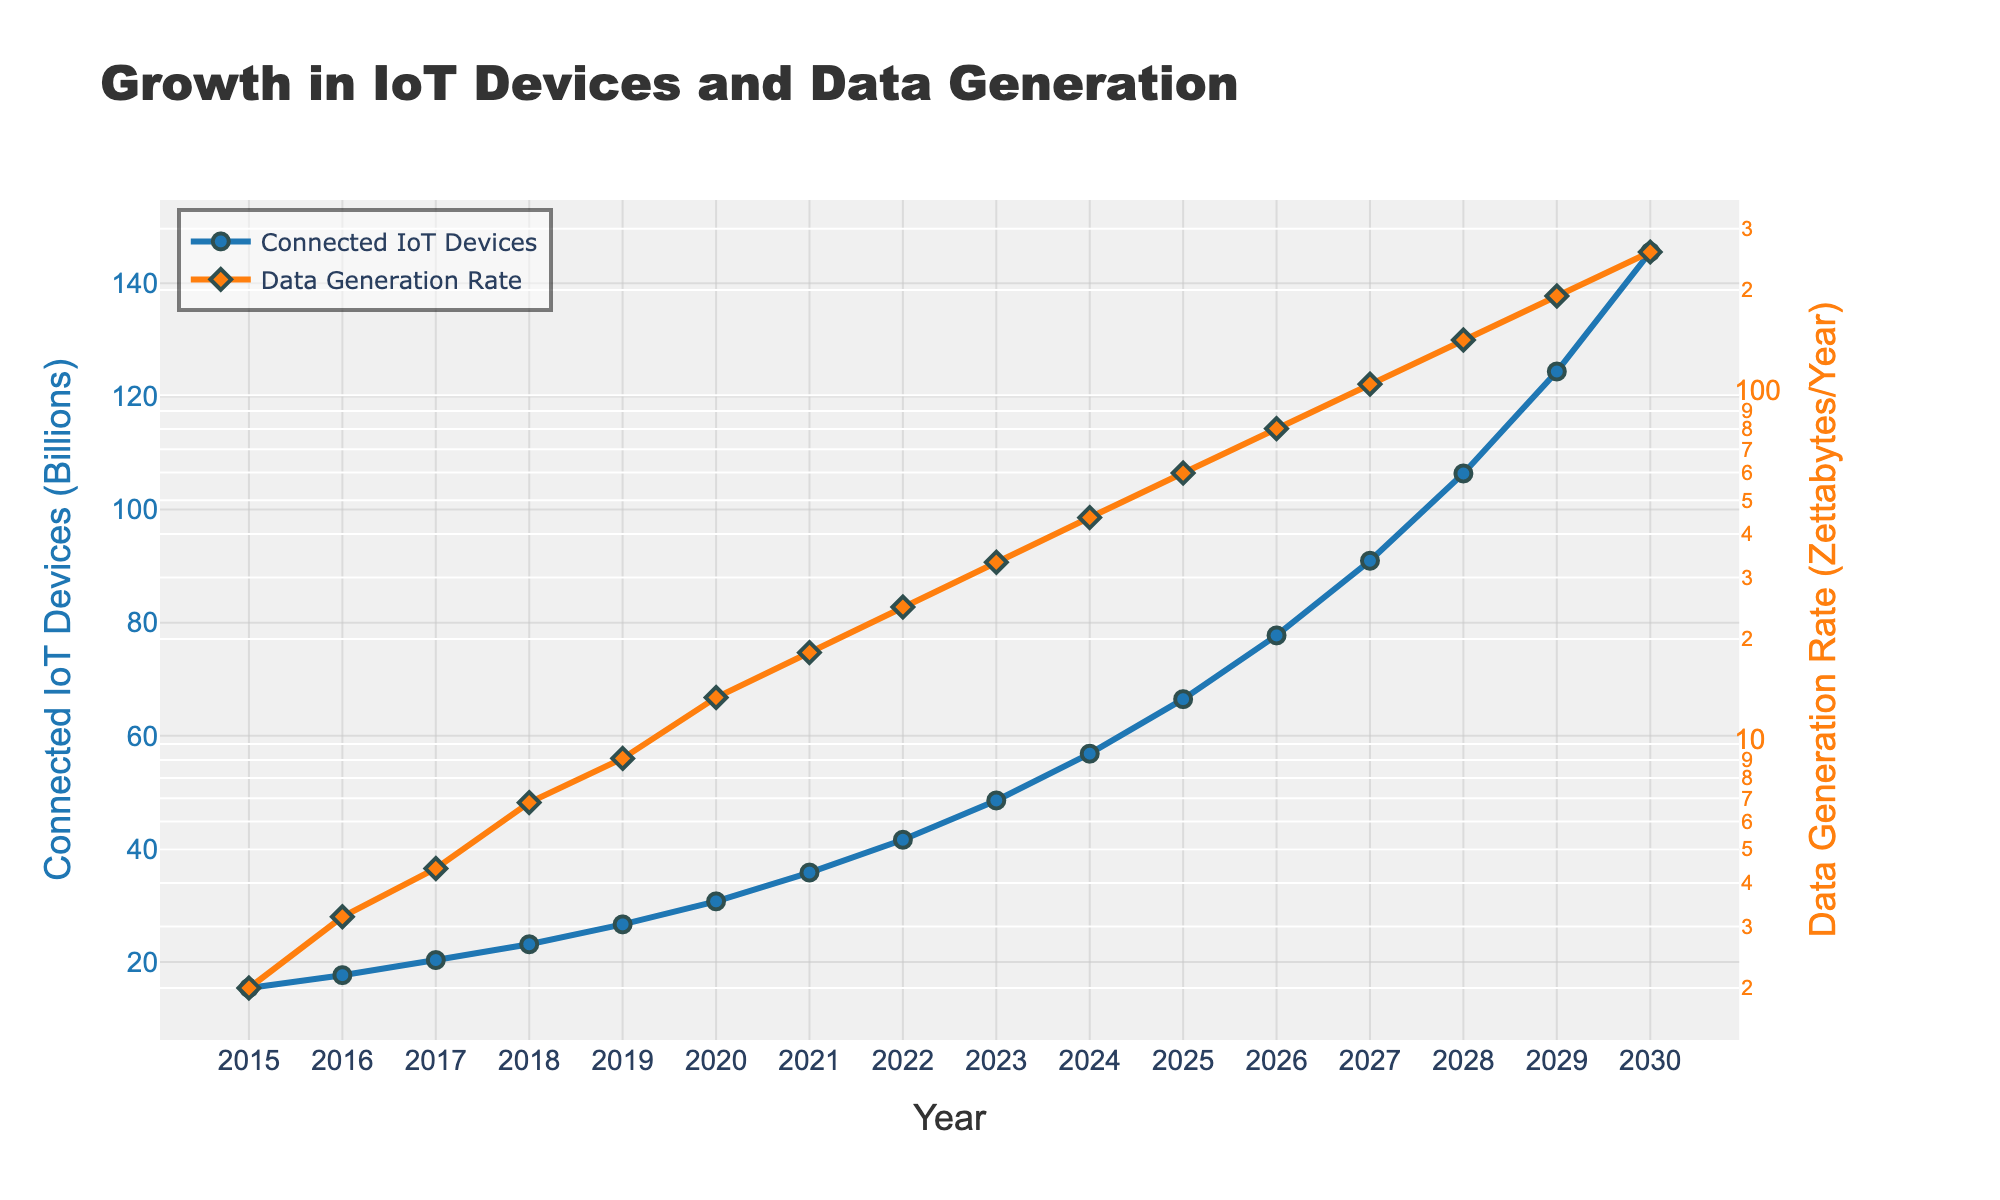What is the data generation rate in 2023? In 2023, the line with the diamond markers for the data generation rate indicates 33.2 Zettabytes/Year.
Answer: 33.2 Zettabytes/Year Which year saw the number of connected IoT devices first exceed 50 billion? The graph shows that in 2024, the amount of connected IoT devices reaches 56.84 billion, marking the first year above 50 billion.
Answer: 2024 What is the rate of increase in connected IoT devices between 2017 and 2020? Subtract the 2017 value from the 2020 value: 30.73 billion (2020) - 20.35 billion (2017) = 10.38 billion.
Answer: 10.38 billion By how much did the data generation rate increase from 2015 to 2030? Subtract the data generation rate in 2015 from the rate in 2030: 257.2 Zettabytes/Year (2030) - 2 Zettabytes/Year (2015) = 255.2 Zettabytes/Year.
Answer: 255.2 Zettabytes/Year Which increased more between 2019 and 2026, the number of connected IoT devices or the data generation rate? Connected IoT devices increased from 26.66 billion (2019) to 77.75 billion (2026), a rise of 51.09 billion. Data generation rate increased from 9.1 Zettabytes/Year (2019) to 80.2 Zettabytes/Year (2026), a rise of 71.1 Zettabytes/Year.
Answer: Data generation rate What is the average number of connected IoT devices from 2015 to 2020? Sum the values from 2015 to 2020, then divide by the number of years: (15.41 + 17.68 + 20.35 + 23.14 + 26.66 + 30.73) / 6 = 22.66 billion (approx).
Answer: 22.66 billion In which year did the data generation rate experience the largest single-year growth, and what was the amount? The largest growth occurs between 2022 and 2023, increasing from 24.7 to 33.2 zettabytes/year, a difference of 8.5 zettabytes/year.
Answer: 2023, 8.5 zettabytes/year How does the trend in the number of connected IoT devices compare to the trend in the data generation rate over the years? Both trends show a consistent increase over the years, but the data generation rate follows a steeper upward trend when viewed on a logarithmic scale, indicating an exponential growth compared to a more linear growth in IoT devices.
Answer: Exponential What's the approximate ratio of data generation rate to connected IoT devices in 2025? Divide the data generation rate by the number of IoT devices for 2025: 59.8 Zettabytes/Year / 66.48 billion = approximately 0.9 Zettabytes/Year per billion devices.
Answer: 0.9 Zettabytes/Year per billion devices 